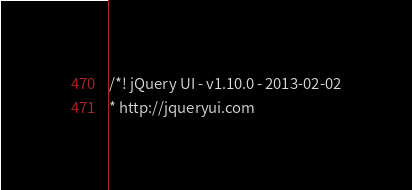Convert code to text. <code><loc_0><loc_0><loc_500><loc_500><_CSS_>/*! jQuery UI - v1.10.0 - 2013-02-02
* http://jqueryui.com</code> 